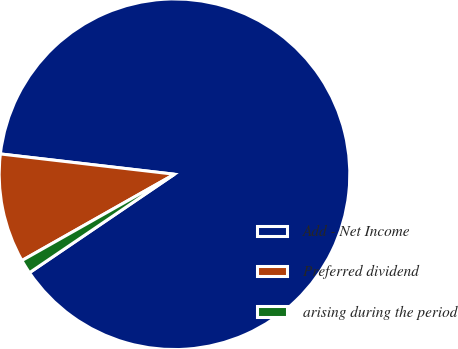<chart> <loc_0><loc_0><loc_500><loc_500><pie_chart><fcel>Add - Net Income<fcel>Preferred dividend<fcel>arising during the period<nl><fcel>88.66%<fcel>10.04%<fcel>1.3%<nl></chart> 